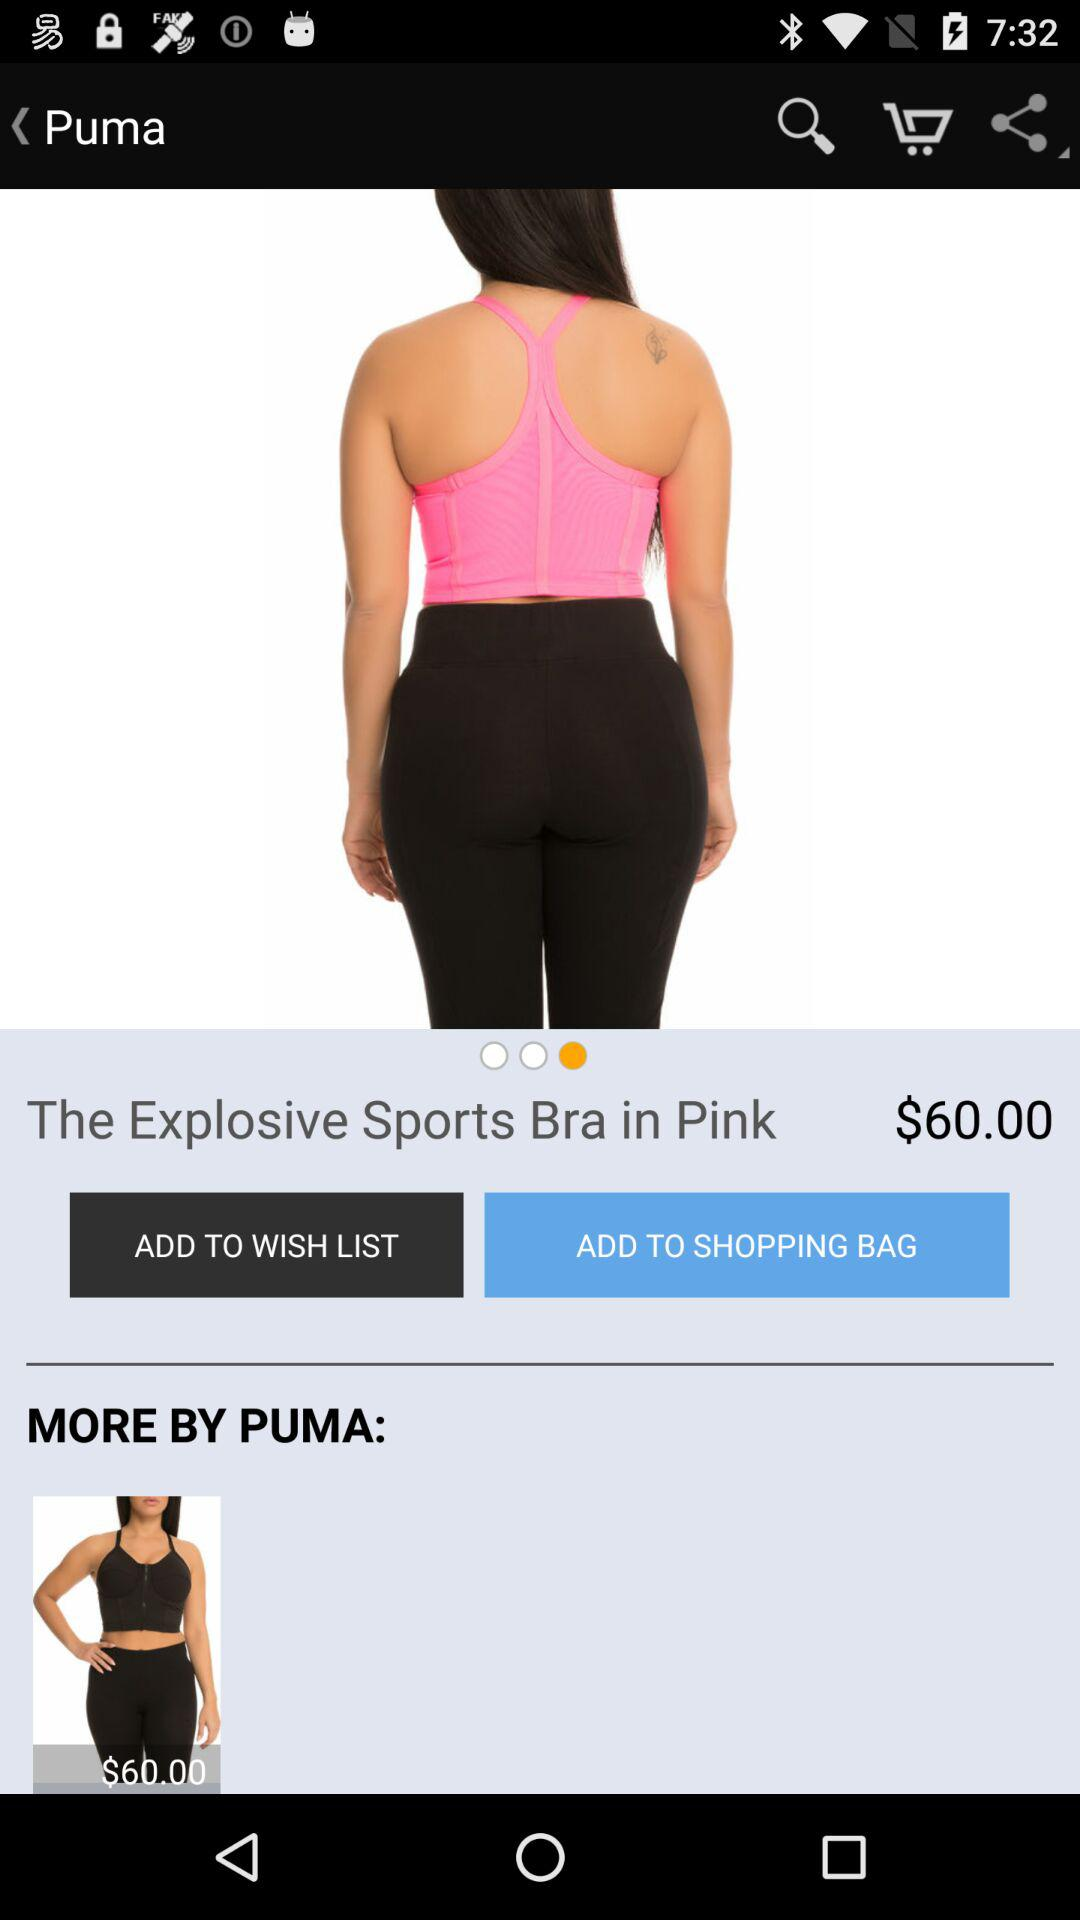What is the price of the product? The price of the product is $60.00. 